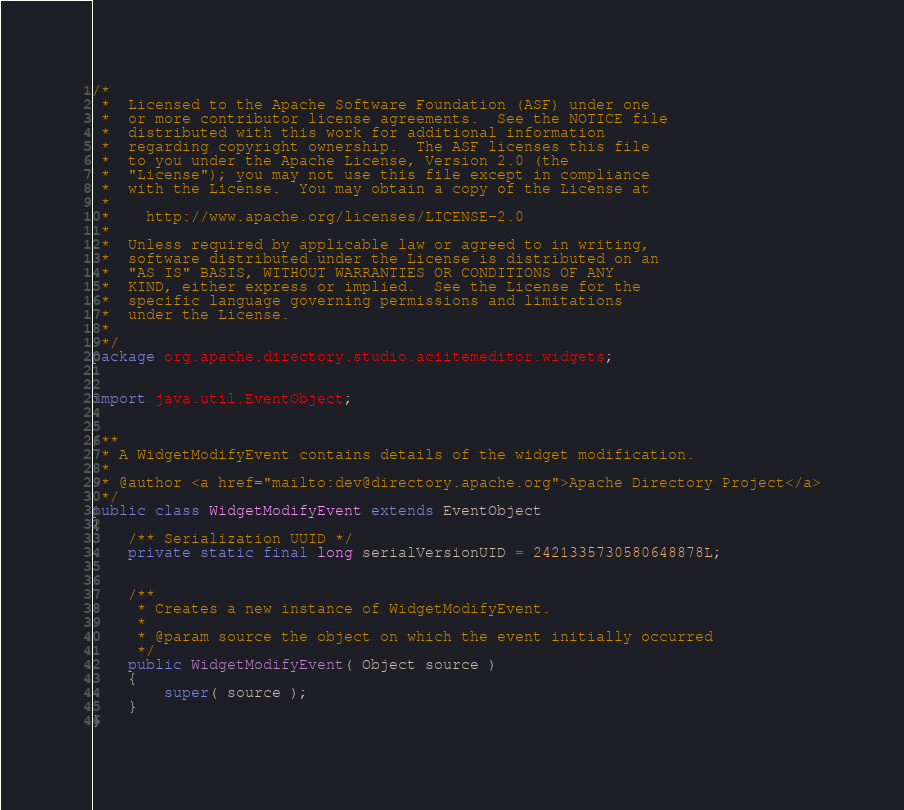Convert code to text. <code><loc_0><loc_0><loc_500><loc_500><_Java_>/*
 *  Licensed to the Apache Software Foundation (ASF) under one
 *  or more contributor license agreements.  See the NOTICE file
 *  distributed with this work for additional information
 *  regarding copyright ownership.  The ASF licenses this file
 *  to you under the Apache License, Version 2.0 (the
 *  "License"); you may not use this file except in compliance
 *  with the License.  You may obtain a copy of the License at
 *  
 *    http://www.apache.org/licenses/LICENSE-2.0
 *  
 *  Unless required by applicable law or agreed to in writing,
 *  software distributed under the License is distributed on an
 *  "AS IS" BASIS, WITHOUT WARRANTIES OR CONDITIONS OF ANY
 *  KIND, either express or implied.  See the License for the
 *  specific language governing permissions and limitations
 *  under the License. 
 *  
 */
package org.apache.directory.studio.aciitemeditor.widgets;


import java.util.EventObject;


/**
 * A WidgetModifyEvent contains details of the widget modification.
 *
 * @author <a href="mailto:dev@directory.apache.org">Apache Directory Project</a>
 */
public class WidgetModifyEvent extends EventObject
{
    /** Serialization UUID */
    private static final long serialVersionUID = 2421335730580648878L;


    /**
     * Creates a new instance of WidgetModifyEvent.
     *
     * @param source the object on which the event initially occurred
     */
    public WidgetModifyEvent( Object source )
    {
        super( source );
    }
}
</code> 